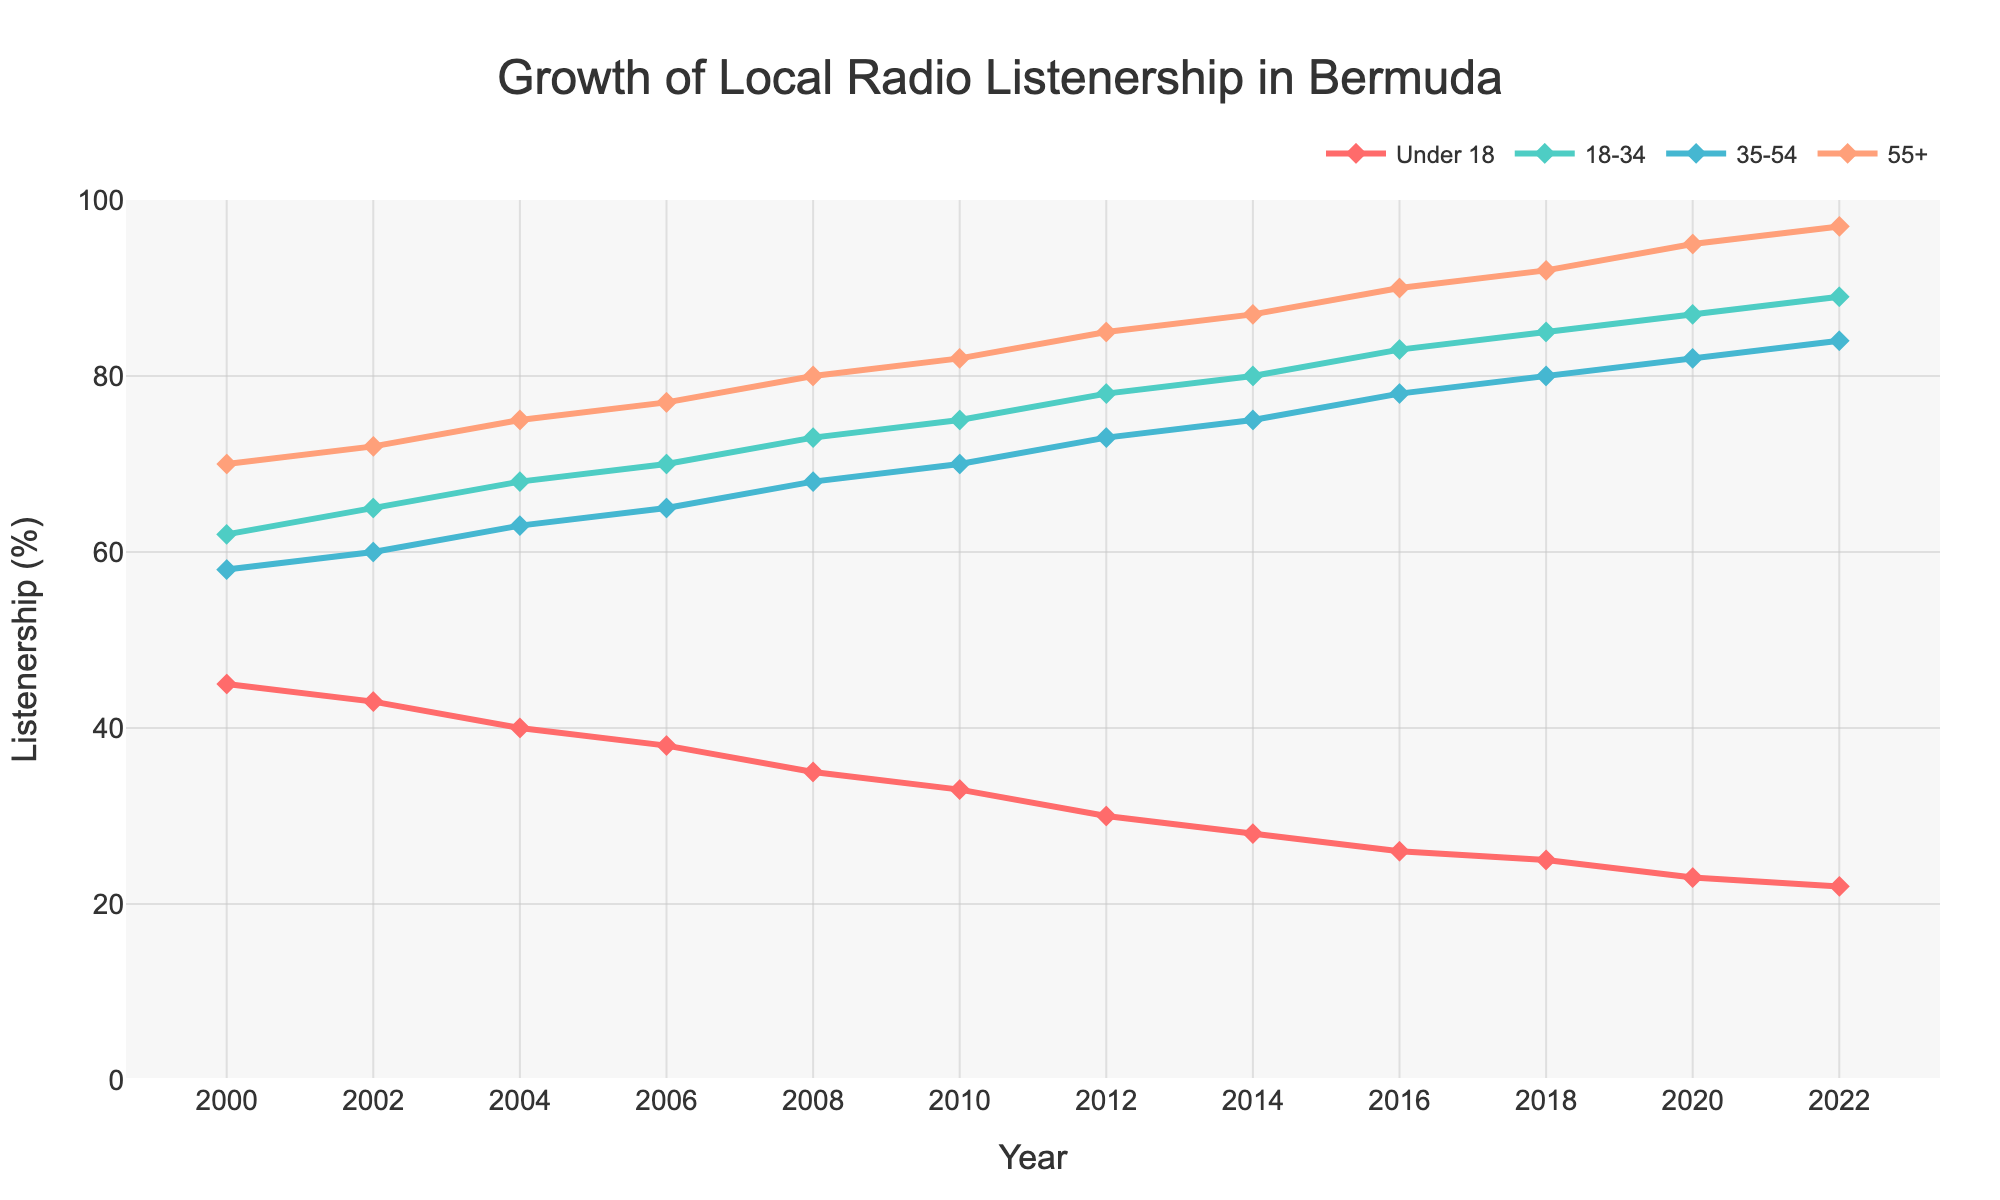What is the overall trend of radio listenership for the age group 18-34 from 2000 to 2022? To determine the overall trend, we observe the line representing the 18-34 age group from 2000 to 2022. The line shows a steady increase in listenership over the years, starting at 62% in 2000 and ending at 89% in 2022. This indicates a positive trend.
Answer: Positive trend Which age group had the highest increase in listenership from 2000 to 2022? To find the highest increase, we need to compare the difference between the listenership percentages of each group in 2000 and 2022. The 55+ age group increased from 70% to 97%, which is a 27% increase. This is the highest among all age groups.
Answer: 55+ age group Between 2008 and 2018, which age group exhibited the most significant rise in listenership? To determine this, we compare the changes in listenership percentages for each age group between 2008 and 2018. The age group 18-34 increased from 73% to 85%, which is a 12% rise, the most significant among all age groups during this period.
Answer: 18-34 age group How does the listenership of the Under 18 age group in 2022 compare to the 55+ age group in 2000? We compare the listenership values of Under 18 in 2022, which is 22%, to the 55+ in 2000, which is 70%. The 55+ age group in 2000 had a significantly higher listenership than the Under 18 group in 2022.
Answer: 55+ age group in 2000 was higher Which age group consistently had the highest listenership throughout the entire timeframe? By observing the lines for each age group across the entire timeline from 2000 to 2022, the 55+ age group consistently maintained the highest listenership percentages, peaking at 97% in 2022.
Answer: 55+ age group Compare the listenership trends of the Under 18 and 35-54 age groups from 2000 to 2022. The Under 18 age group shows a continuous decline in listenership from 45% in 2000 to 22% in 2022. Conversely, the 35-54 age group shows an increasing trend from 58% in 2000 to 84% in 2022.
Answer: Under 18 declined, 35-54 increased What was the percentage difference in listenership between the 18-34 and 35-54 age groups in 2010? In 2010, the listenership for the 18-34 age group was 75% and for the 35-54 age group was 70%. The percentage difference is 75% - 70% = 5%.
Answer: 5% How does the listenership of the 35-54 age group in 2018 compare to the Under 18 age group in the same year? In 2018, the listenership of the 35-54 age group was 80%, whereas the listenership of the Under 18 age group was 25%. The 35-54 age group had significantly higher listenership.
Answer: 35-54 age group was higher What is the average listenership across all age groups in the year 2016? To find the average, we sum the listenership percentages for all age groups in 2016 (26% + 83% + 78% + 90%) and divide by 4. The sum is 277% and the average is 277/4 = 69.25%.
Answer: 69.25% 